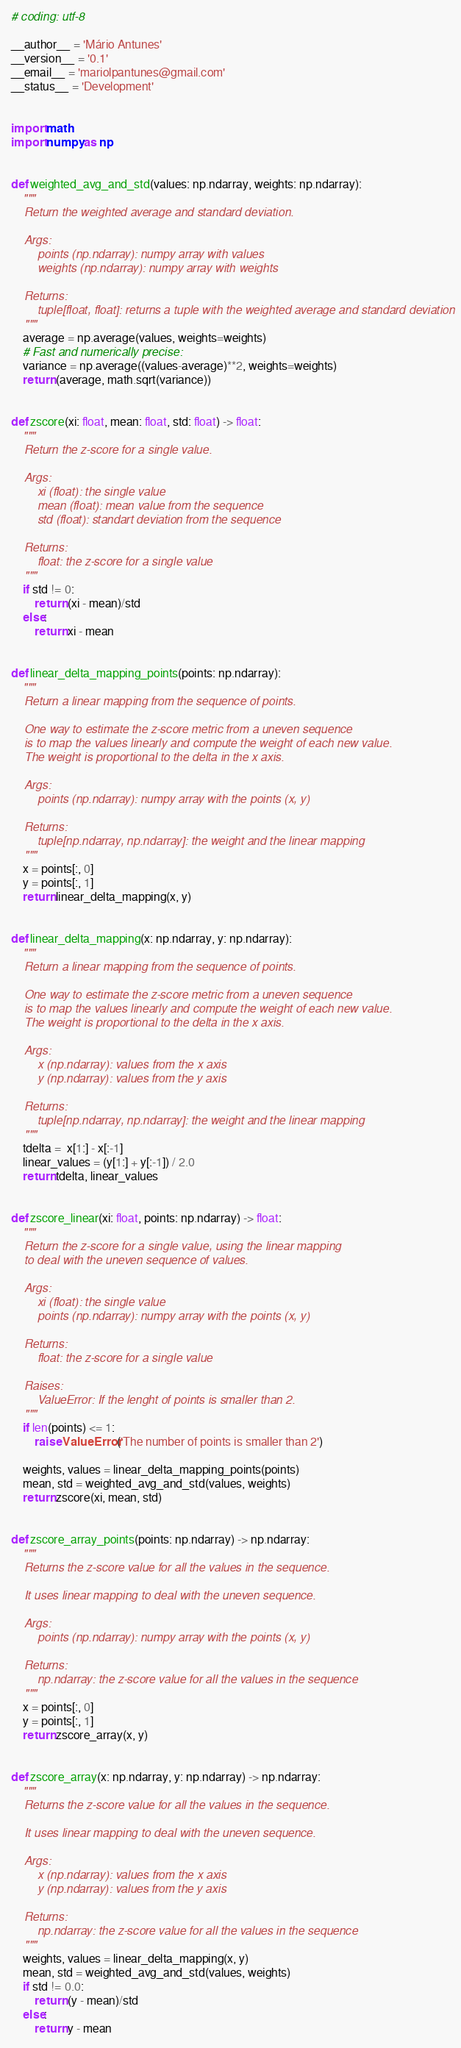<code> <loc_0><loc_0><loc_500><loc_500><_Python_># coding: utf-8

__author__ = 'Mário Antunes'
__version__ = '0.1'
__email__ = 'mariolpantunes@gmail.com'
__status__ = 'Development'


import math
import numpy as np


def weighted_avg_and_std(values: np.ndarray, weights: np.ndarray):
    """
    Return the weighted average and standard deviation.
    
    Args:
        points (np.ndarray): numpy array with values
        weights (np.ndarray): numpy array with weights
    
    Returns:
        tuple[float, float]: returns a tuple with the weighted average and standard deviation
    """
    average = np.average(values, weights=weights)
    # Fast and numerically precise:
    variance = np.average((values-average)**2, weights=weights)
    return (average, math.sqrt(variance))


def zscore(xi: float, mean: float, std: float) -> float:
    """
    Return the z-score for a single value.
    
    Args:
        xi (float): the single value
        mean (float): mean value from the sequence
        std (float): standart deviation from the sequence
    
    Returns:
        float: the z-score for a single value
    """
    if std != 0:
        return (xi - mean)/std
    else:
        return xi - mean


def linear_delta_mapping_points(points: np.ndarray):
    """
    Return a linear mapping from the sequence of points.

    One way to estimate the z-score metric from a uneven sequence
    is to map the values linearly and compute the weight of each new value.
    The weight is proportional to the delta in the x axis.
    
    Args:
        points (np.ndarray): numpy array with the points (x, y)
    
    Returns:
        tuple[np.ndarray, np.ndarray]: the weight and the linear mapping
    """
    x = points[:, 0]
    y = points[:, 1]
    return linear_delta_mapping(x, y)


def linear_delta_mapping(x: np.ndarray, y: np.ndarray):
    """
    Return a linear mapping from the sequence of points.

    One way to estimate the z-score metric from a uneven sequence
    is to map the values linearly and compute the weight of each new value.
    The weight is proportional to the delta in the x axis.
    
    Args:
        x (np.ndarray): values from the x axis
        y (np.ndarray): values from the y axis
    
    Returns:
        tuple[np.ndarray, np.ndarray]: the weight and the linear mapping
    """
    tdelta =  x[1:] - x[:-1]
    linear_values = (y[1:] + y[:-1]) / 2.0
    return tdelta, linear_values


def zscore_linear(xi: float, points: np.ndarray) -> float:
    """
    Return the z-score for a single value, using the linear mapping
    to deal with the uneven sequence of values.
    
    Args:
        xi (float): the single value
        points (np.ndarray): numpy array with the points (x, y)
    
    Returns:
        float: the z-score for a single value
    
    Raises:
        ValueError: If the lenght of points is smaller than 2.
    """
    if len(points) <= 1:
        raise ValueError('The number of points is smaller than 2')

    weights, values = linear_delta_mapping_points(points)
    mean, std = weighted_avg_and_std(values, weights)
    return zscore(xi, mean, std)


def zscore_array_points(points: np.ndarray) -> np.ndarray:
    """
    Returns the z-score value for all the values in the sequence.

    It uses linear mapping to deal with the uneven sequence.
    
    Args:
        points (np.ndarray): numpy array with the points (x, y)
    
    Returns:
        np.ndarray: the z-score value for all the values in the sequence
    """
    x = points[:, 0]
    y = points[:, 1]
    return zscore_array(x, y)


def zscore_array(x: np.ndarray, y: np.ndarray) -> np.ndarray:
    """
    Returns the z-score value for all the values in the sequence.

    It uses linear mapping to deal with the uneven sequence.
    
    Args:
        x (np.ndarray): values from the x axis
        y (np.ndarray): values from the y axis
    
    Returns:
        np.ndarray: the z-score value for all the values in the sequence
    """
    weights, values = linear_delta_mapping(x, y)
    mean, std = weighted_avg_and_std(values, weights)
    if std != 0.0:
        return (y - mean)/std
    else:
        return y - mean
</code> 